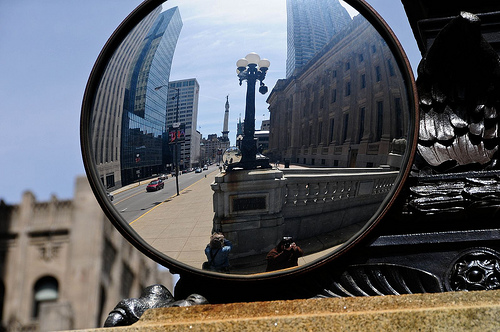<image>
Is there a lightpost to the right of the building? Yes. From this viewpoint, the lightpost is positioned to the right side relative to the building. 